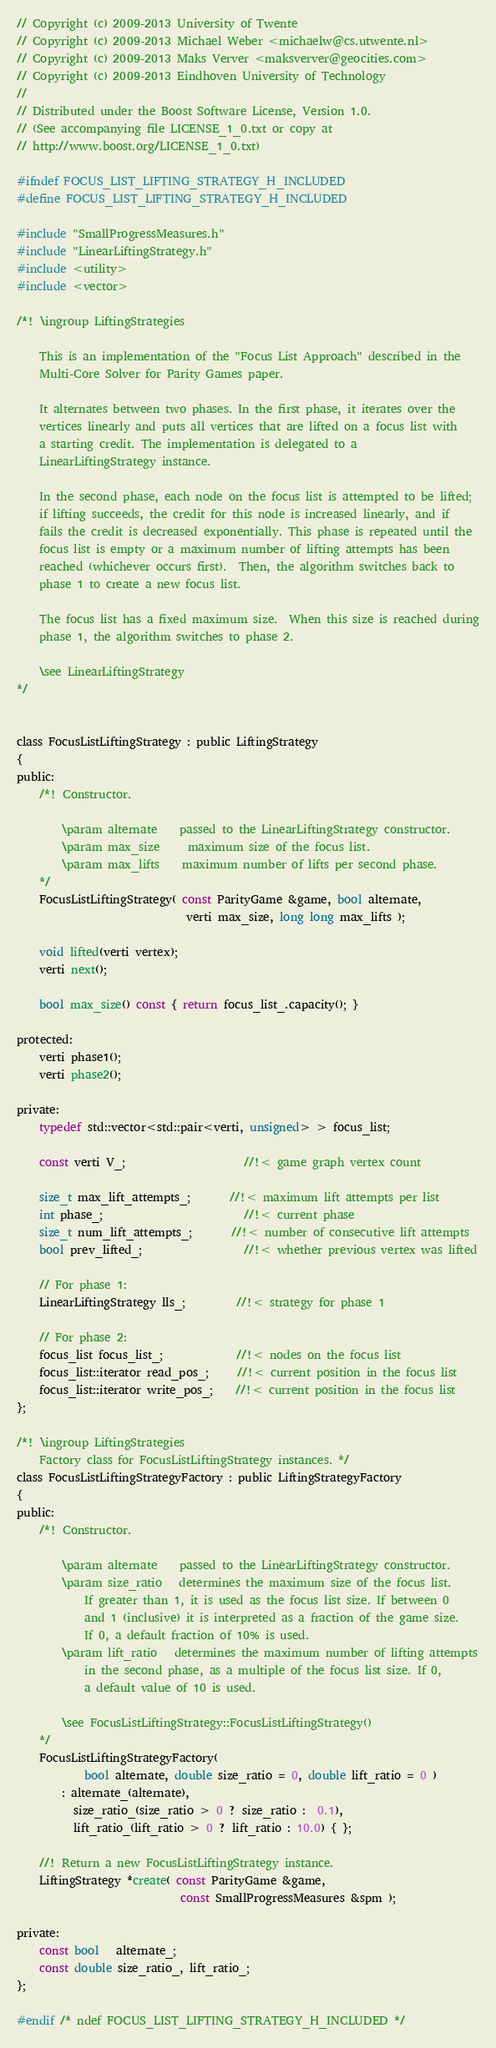Convert code to text. <code><loc_0><loc_0><loc_500><loc_500><_C_>// Copyright (c) 2009-2013 University of Twente
// Copyright (c) 2009-2013 Michael Weber <michaelw@cs.utwente.nl>
// Copyright (c) 2009-2013 Maks Verver <maksverver@geocities.com>
// Copyright (c) 2009-2013 Eindhoven University of Technology
//
// Distributed under the Boost Software License, Version 1.0.
// (See accompanying file LICENSE_1_0.txt or copy at
// http://www.boost.org/LICENSE_1_0.txt)

#ifndef FOCUS_LIST_LIFTING_STRATEGY_H_INCLUDED
#define FOCUS_LIST_LIFTING_STRATEGY_H_INCLUDED

#include "SmallProgressMeasures.h"
#include "LinearLiftingStrategy.h"
#include <utility>
#include <vector>

/*! \ingroup LiftingStrategies

    This is an implementation of the "Focus List Approach" described in the
    Multi-Core Solver for Parity Games paper.

    It alternates between two phases. In the first phase, it iterates over the
    vertices linearly and puts all vertices that are lifted on a focus list with
    a starting credit. The implementation is delegated to a
    LinearLiftingStrategy instance.

    In the second phase, each node on the focus list is attempted to be lifted;
    if lifting succeeds, the credit for this node is increased linearly, and if
    fails the credit is decreased exponentially. This phase is repeated until the
    focus list is empty or a maximum number of lifting attempts has been
    reached (whichever occurs first).  Then, the algorithm switches back to
    phase 1 to create a new focus list.

    The focus list has a fixed maximum size.  When this size is reached during
    phase 1, the algorithm switches to phase 2.

    \see LinearLiftingStrategy
*/


class FocusListLiftingStrategy : public LiftingStrategy
{
public:
    /*! Constructor.

        \param alternate    passed to the LinearLiftingStrategy constructor.
        \param max_size     maximum size of the focus list.
        \param max_lifts    maximum number of lifts per second phase.
    */
    FocusListLiftingStrategy( const ParityGame &game, bool alternate,
                              verti max_size, long long max_lifts );

    void lifted(verti vertex);
    verti next();

    bool max_size() const { return focus_list_.capacity(); }

protected:
    verti phase1();
    verti phase2();

private:
    typedef std::vector<std::pair<verti, unsigned> > focus_list;

    const verti V_;                     //!< game graph vertex count

    size_t max_lift_attempts_;       //!< maximum lift attempts per list
    int phase_;                         //!< current phase
    size_t num_lift_attempts_;       //!< number of consecutive lift attempts
    bool prev_lifted_;                  //!< whether previous vertex was lifted

    // For phase 1:
    LinearLiftingStrategy lls_;         //!< strategy for phase 1

    // For phase 2:
    focus_list focus_list_;             //!< nodes on the focus list
    focus_list::iterator read_pos_;     //!< current position in the focus list
    focus_list::iterator write_pos_;    //!< current position in the focus list
};

/*! \ingroup LiftingStrategies
    Factory class for FocusListLiftingStrategy instances. */
class FocusListLiftingStrategyFactory : public LiftingStrategyFactory
{
public:
    /*! Constructor.

        \param alternate    passed to the LinearLiftingStrategy constructor.
        \param size_ratio   determines the maximum size of the focus list.
            If greater than 1, it is used as the focus list size. If between 0
            and 1 (inclusive) it is interpreted as a fraction of the game size.
            If 0, a default fraction of 10% is used.
        \param lift_ratio   determines the maximum number of lifting attempts
            in the second phase, as a multiple of the focus list size. If 0,
            a default value of 10 is used.

        \see FocusListLiftingStrategy::FocusListLiftingStrategy()
    */
    FocusListLiftingStrategyFactory(
            bool alternate, double size_ratio = 0, double lift_ratio = 0 )
        : alternate_(alternate),
          size_ratio_(size_ratio > 0 ? size_ratio :  0.1),
          lift_ratio_(lift_ratio > 0 ? lift_ratio : 10.0) { };

    //! Return a new FocusListLiftingStrategy instance.
    LiftingStrategy *create( const ParityGame &game,
                             const SmallProgressMeasures &spm );

private:
    const bool   alternate_;
    const double size_ratio_, lift_ratio_;
};

#endif /* ndef FOCUS_LIST_LIFTING_STRATEGY_H_INCLUDED */
</code> 